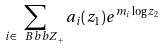<formula> <loc_0><loc_0><loc_500><loc_500>\sum _ { i \in { \ B b b Z } _ { + } } a _ { i } ( z _ { 1 } ) e ^ { m _ { i } \log z _ { 2 } }</formula> 